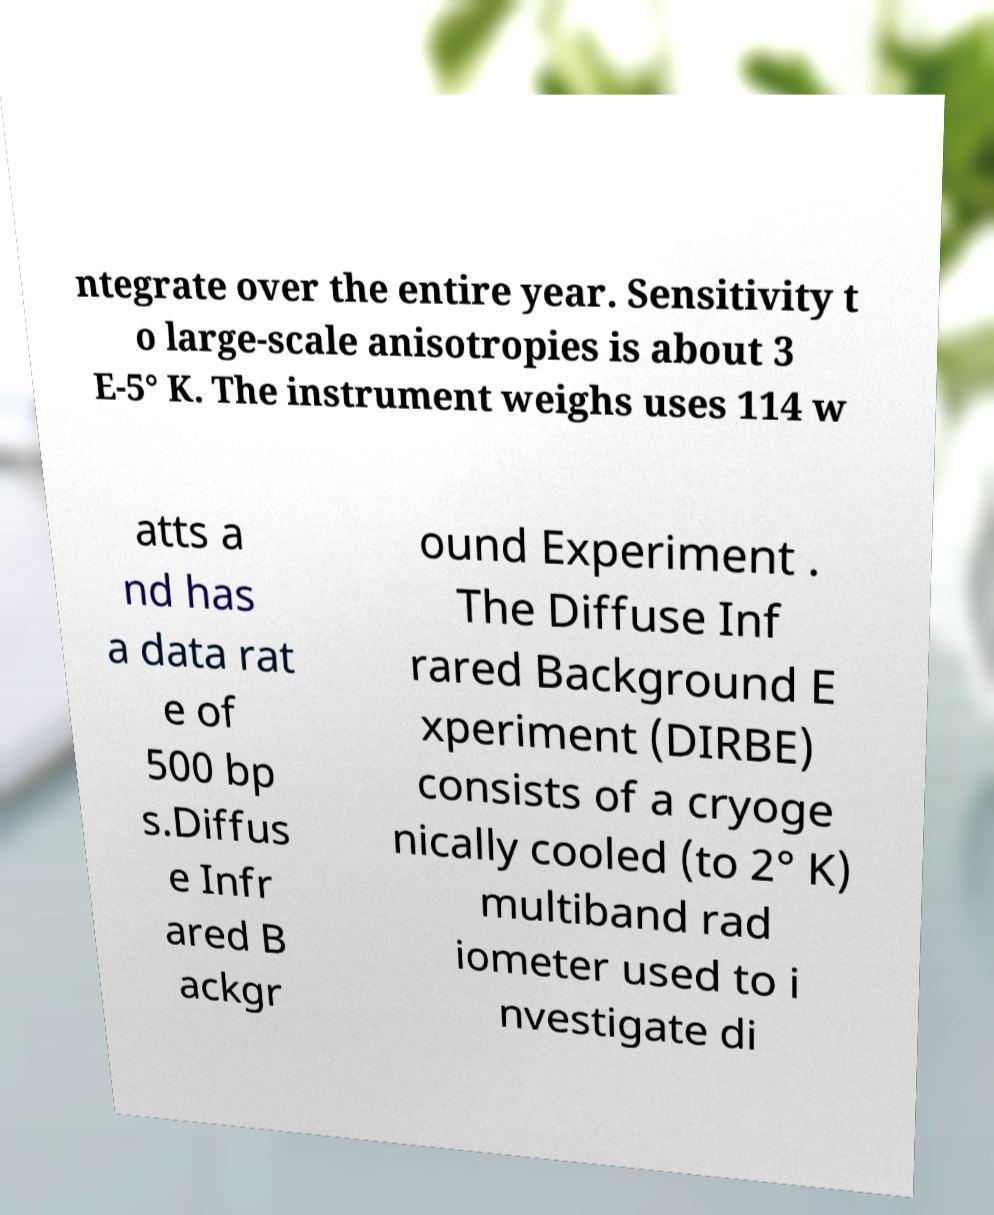Can you read and provide the text displayed in the image?This photo seems to have some interesting text. Can you extract and type it out for me? ntegrate over the entire year. Sensitivity t o large-scale anisotropies is about 3 E-5° K. The instrument weighs uses 114 w atts a nd has a data rat e of 500 bp s.Diffus e Infr ared B ackgr ound Experiment . The Diffuse Inf rared Background E xperiment (DIRBE) consists of a cryoge nically cooled (to 2° K) multiband rad iometer used to i nvestigate di 